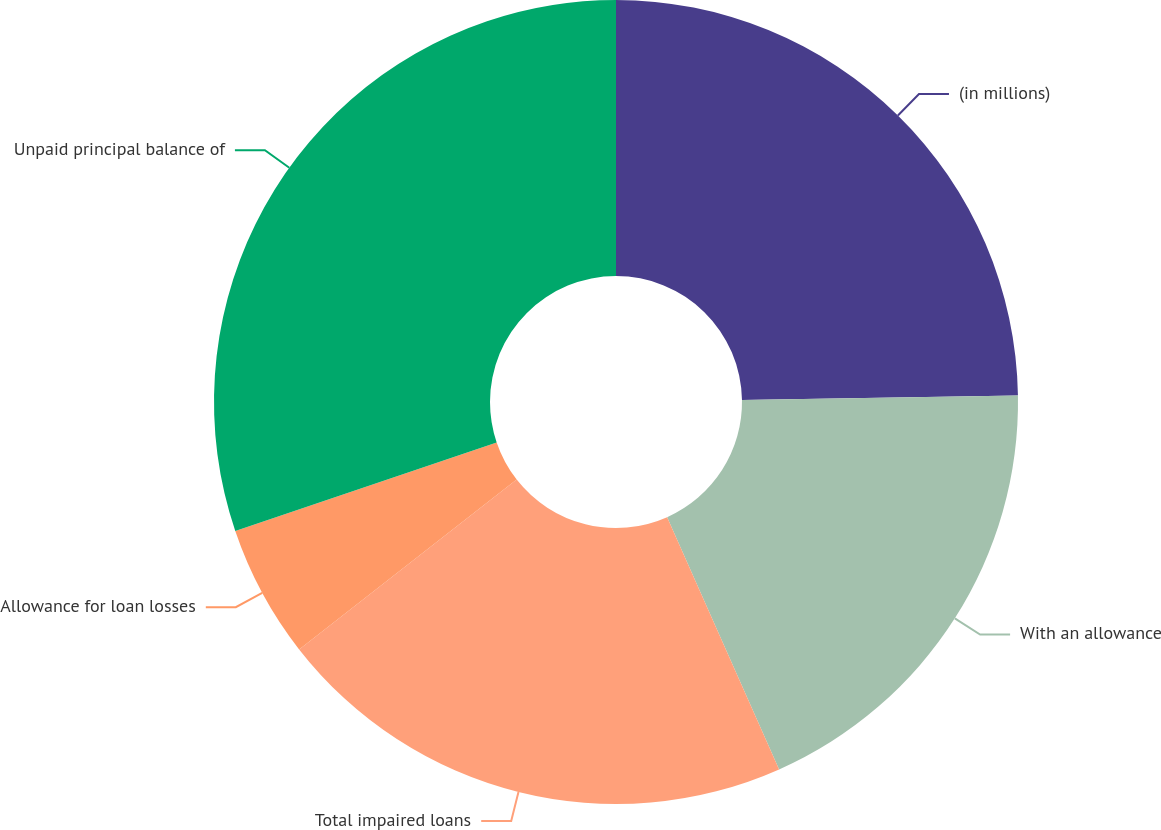Convert chart. <chart><loc_0><loc_0><loc_500><loc_500><pie_chart><fcel>(in millions)<fcel>With an allowance<fcel>Total impaired loans<fcel>Allowance for loan losses<fcel>Unpaid principal balance of<nl><fcel>24.74%<fcel>18.61%<fcel>21.1%<fcel>5.35%<fcel>30.2%<nl></chart> 